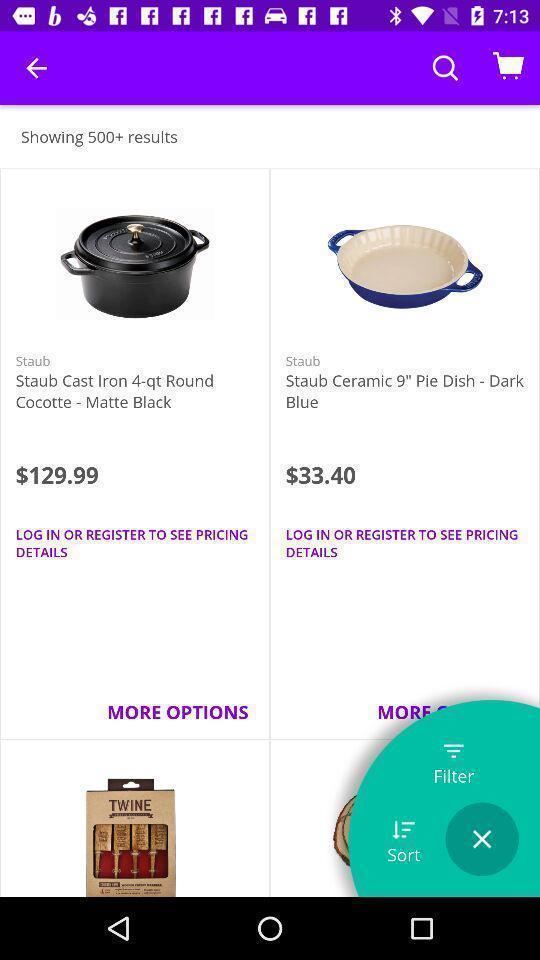What can you discern from this picture? Screen displaying kitchen appliances with its price on shopping app. 